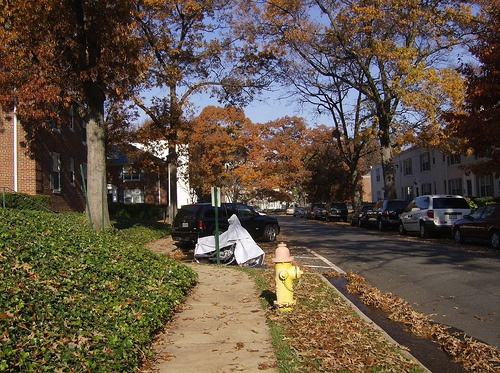Describe the objects in this image and their specific colors. I can see truck in brown, black, gray, darkgray, and maroon tones, car in brown, black, gray, and maroon tones, car in brown, black, gray, darkgray, and darkblue tones, car in brown, black, navy, gray, and darkblue tones, and fire hydrant in brown, khaki, and tan tones in this image. 